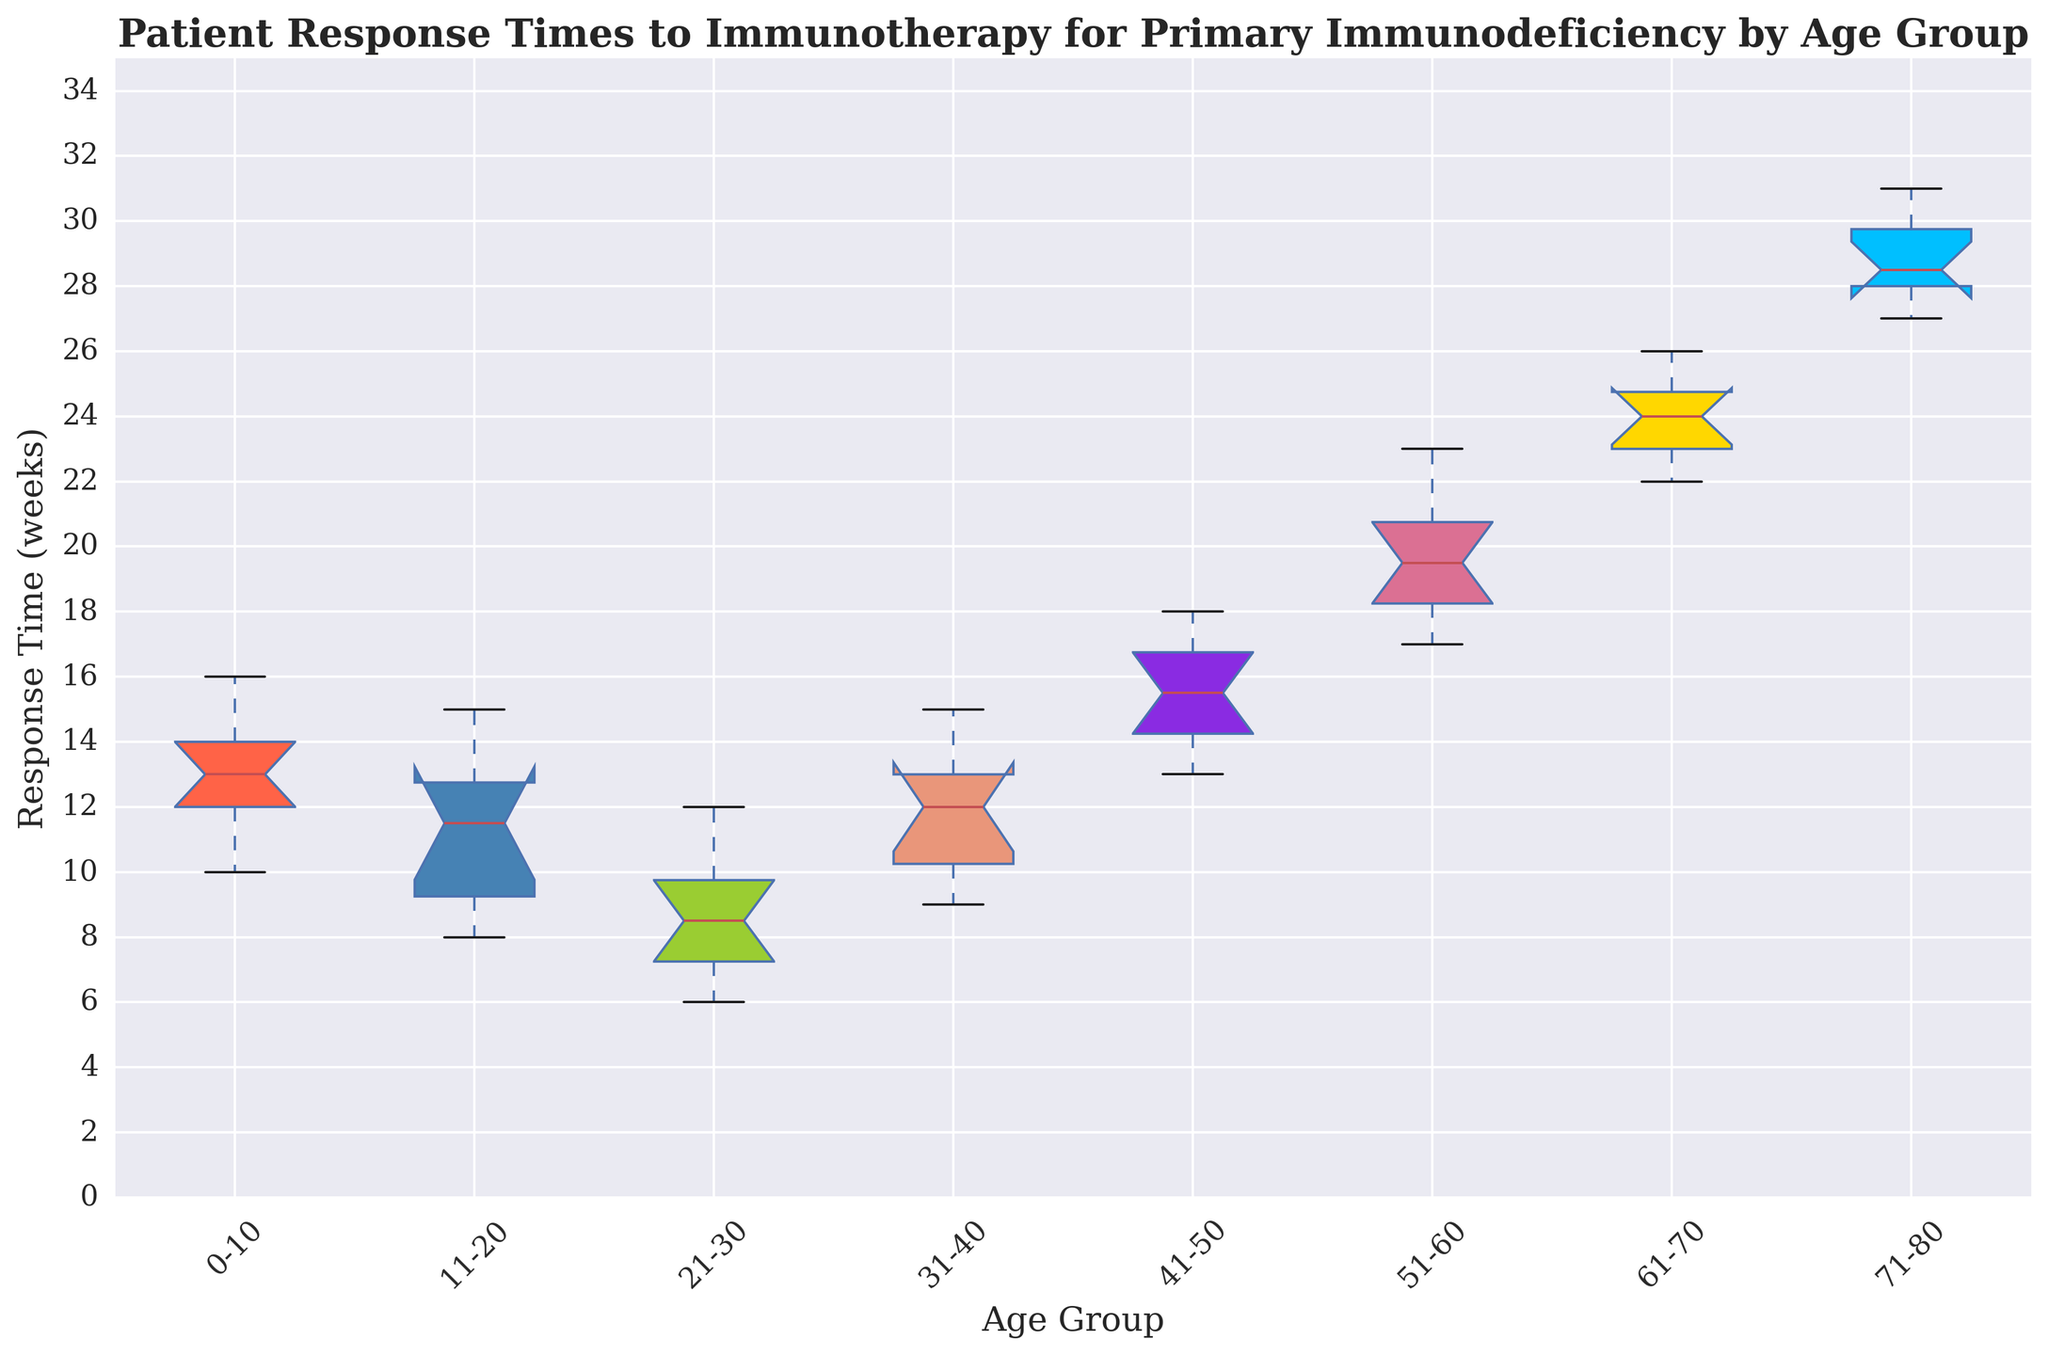What is the median response time for patients in the 0-10 age group? To find the median response time for the 0-10 age group, locate the median line within the box for this group. The median is the value in the middle of the data distribution, where 50% of the data points lie below it.
Answer: 13 weeks Which age group has the highest median response time to immunotherapy? To identify the age group with the highest median response time, compare the median lines in each box plot. The highest median line represents the age group with the highest median response time.
Answer: 71-80 What is the interquartile range (IQR) for the 41-50 age group? The interquartile range is the difference between the third quartile (Q3) and the first quartile (Q1). For the 41-50 age group, identify the top and bottom edges of the box, which represent Q3 and Q1, respectively. The IQR is calculated as Q3 - Q1.
Answer: 16 - 14 = 2 weeks Which age group shows the most variation in response times to immunotherapy? To determine the age group with the most variation, look at the length of the boxes and the range of the whiskers in each box plot. The age group with the longest box and extended whiskers has the most variation.
Answer: 71-80 Is the median response time for the 21-30 age group greater than the lower quartile (Q1) for the 51-60 age group? Locate the median for the 21-30 age group and the lower quartile (Q1) for the 51-60 age group. Compare these two values to determine if the median of the 21-30 age group is greater than the Q1 of the 51-60 age group.
Answer: No Which two age groups have their first quartile (Q1) values equal to 12? Identify the bottom edge of the boxes for all age groups to find the Q1 values. Compare them to determine which two age groups have their Q1 values equal to 12.
Answer: 31-40 and 51-60 How does the median response time change as age groups progress from 0-10 to 71-80? Observe the trend of the median lines across the age groups from 0-10 to 71-80. Note how the median values increase, decrease, or remain consistent to determine the overall trend.
Answer: Increases What is the range of response times for the 61-70 age group? The range is the difference between the maximum and minimum values. For the 61-70 age group, identify the top and bottom whiskers, representing the maximum and minimum response times, and calculate the difference.
Answer: 26 - 22 = 4 weeks Which age group has the smallest interquartile range (IQR)? Compare the lengths of the boxes (representing the IQR) for all the age groups. The smallest box indicates the age group with the smallest IQR.
Answer: 11-20 